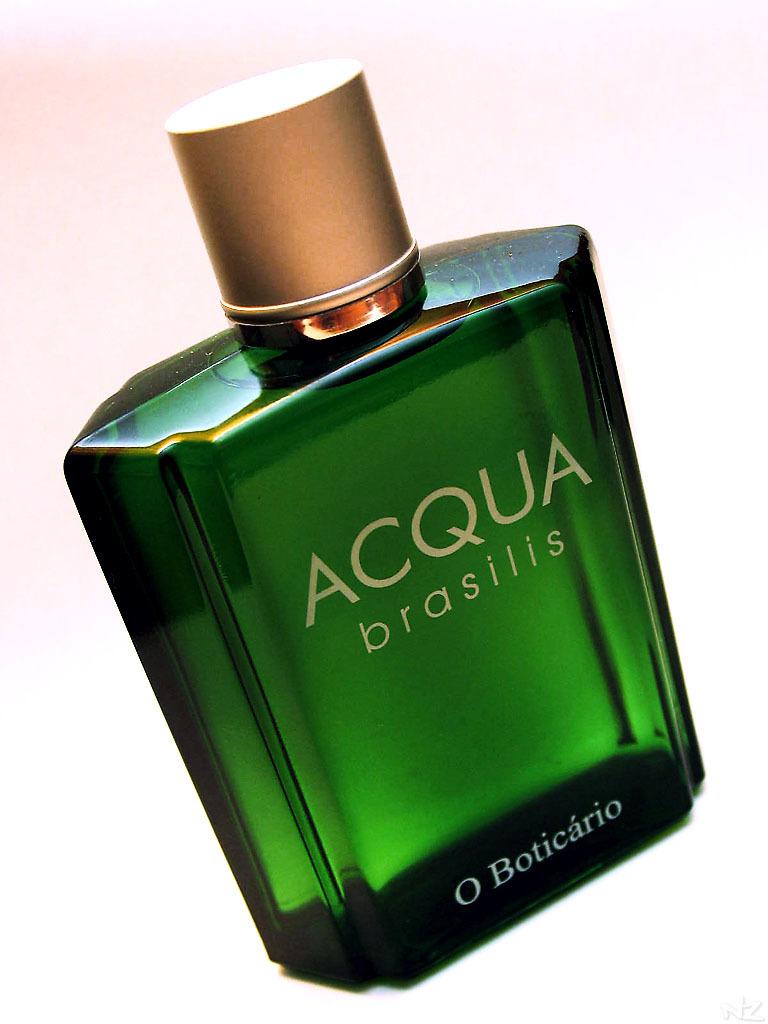What is the name of this perfume?
Keep it short and to the point. Acqua brasilis. What name is at the bottom of the bottle?
Your answer should be compact. Boticario. 